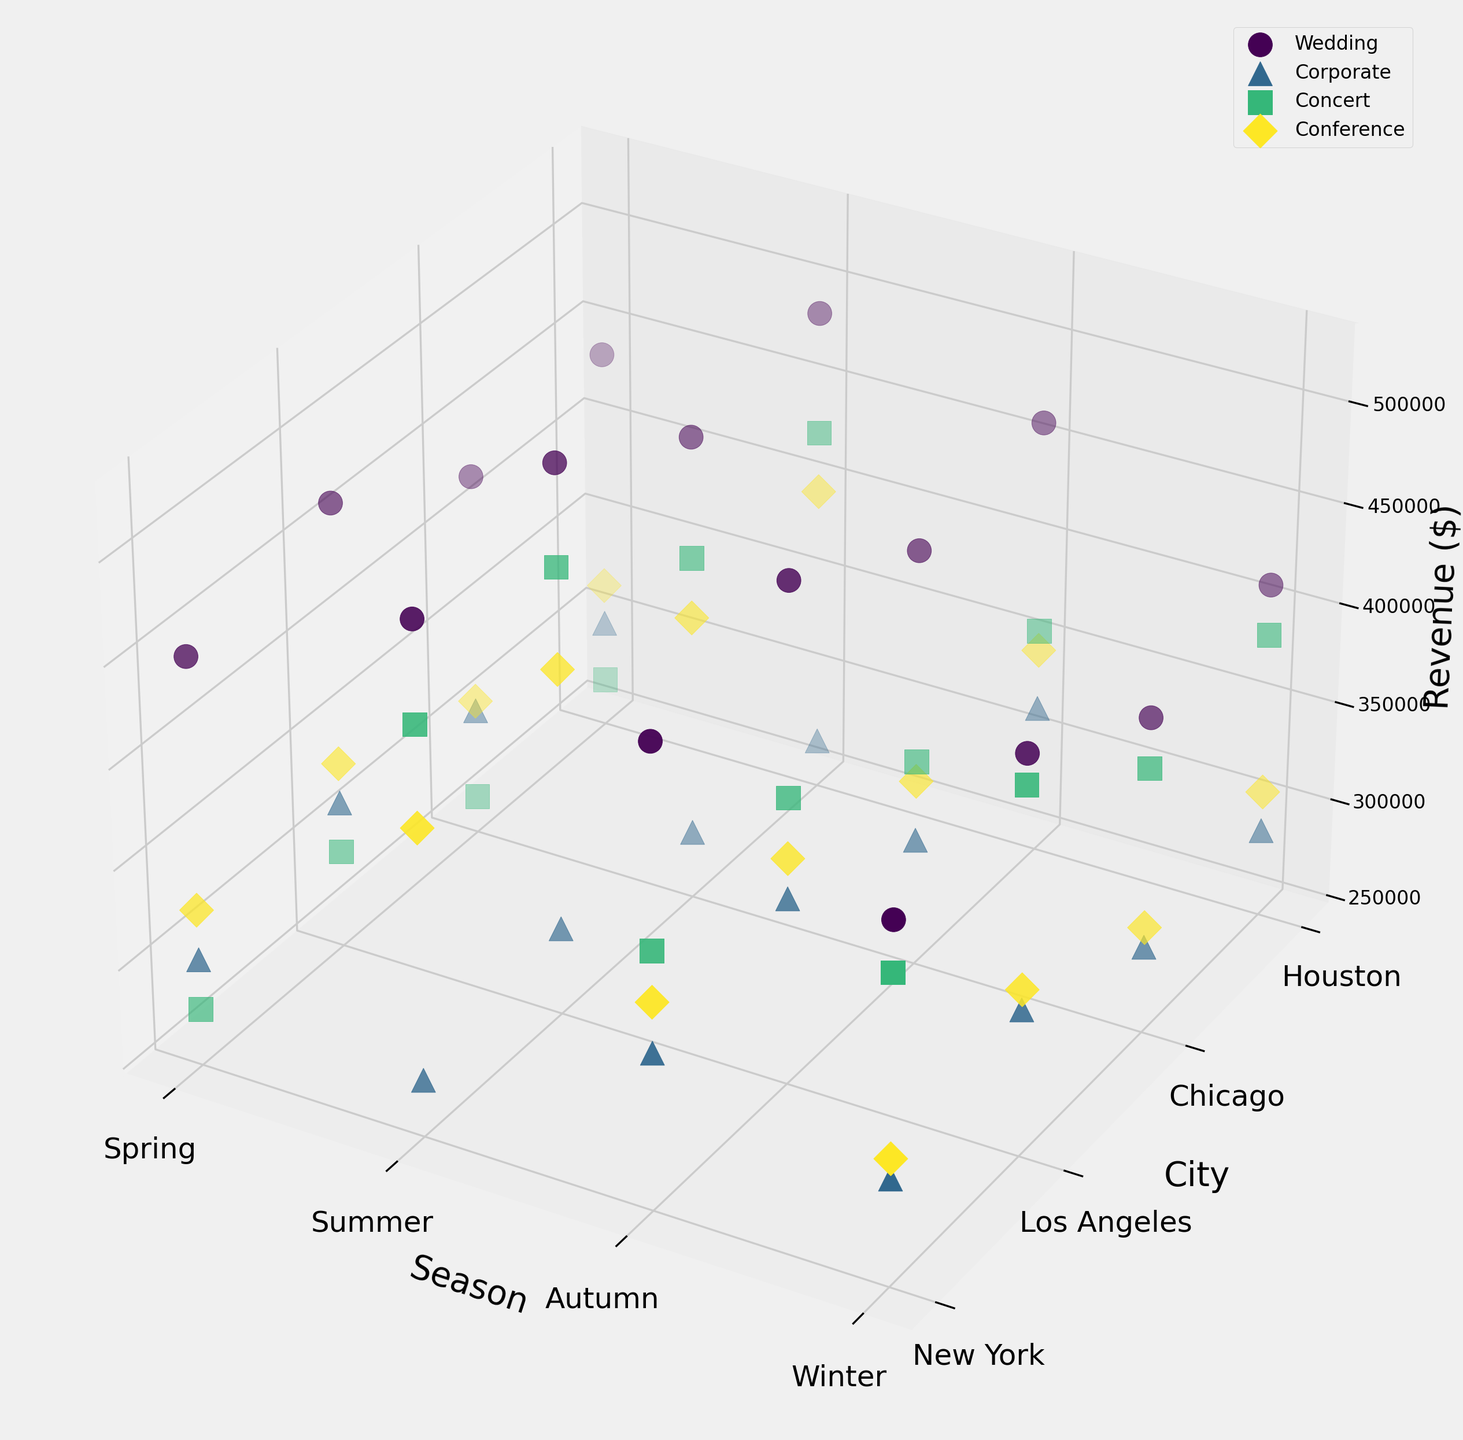Which city generates the highest revenue from concerts during the summer? Locate the data points representing concerts (marked by a specific shape/color) and compare their heights in the summer season. The highest point corresponds to the highest revenue.
Answer: Los Angeles What is the total revenue generated from weddings in New York across all seasons? Identify the points representing New York weddings across all seasons. Sum their heights (revenues): 450000 (Spring) + 500000 (Summer) + 475000 (Autumn) + 425000 (Winter).
Answer: 1850000 Between corporate events in Houston and wedding events in Chicago during winter, which one earns more? Compare the heights of the points for Houston's corporate event and Chicago's wedding event in winter. Houston has 290000 and Chicago has 405000.
Answer: Chicago wedding events What is the average revenue for conferences in Los Angeles across all seasons? Identify the points representing conferences in Los Angeles for all seasons. Sum their heights and divide by 4: (340000 + 420000 + 360000 + 330000) / 4.
Answer: 362500 Which event type in Chicago sees the most consistent revenue across seasons? Observe the range of heights for each event type in Chicago across all seasons. Consistent revenue would mean less variance in height. Corporate events seem to show this consistency.
Answer: Corporate How does the revenue from corporate events in New York during autumn compare to those in spring? Compare the heights of the corporate event points in New York for autumn and spring. Autumn has 325000, spring has 300000.
Answer: Autumn generates more Which season generates the least revenue for conferences in Houston? Compare the heights of the points representing conferences in Houston across all seasons. The shortest point corresponds to the lowest revenue.
Answer: Winter For wedding events, which city shows the greatest increase in revenue from spring to summer? Calculate the difference in revenue between spring and summer for wedding events in each city and find the greatest increase: Los Angeles (520000 - 470000 = 50000), New York (500000 - 450000 = 50000), Chicago (480000 - 430000 = 50000), Houston (490000 - 440000 = 50000).
Answer: All cities showed same increase Which city has the highest average revenue across all event types and seasons? Calculate the average revenue for each city by summing all revenues and dividing by the number of data points (16 per city), then compare.
Answer: Los Angeles 